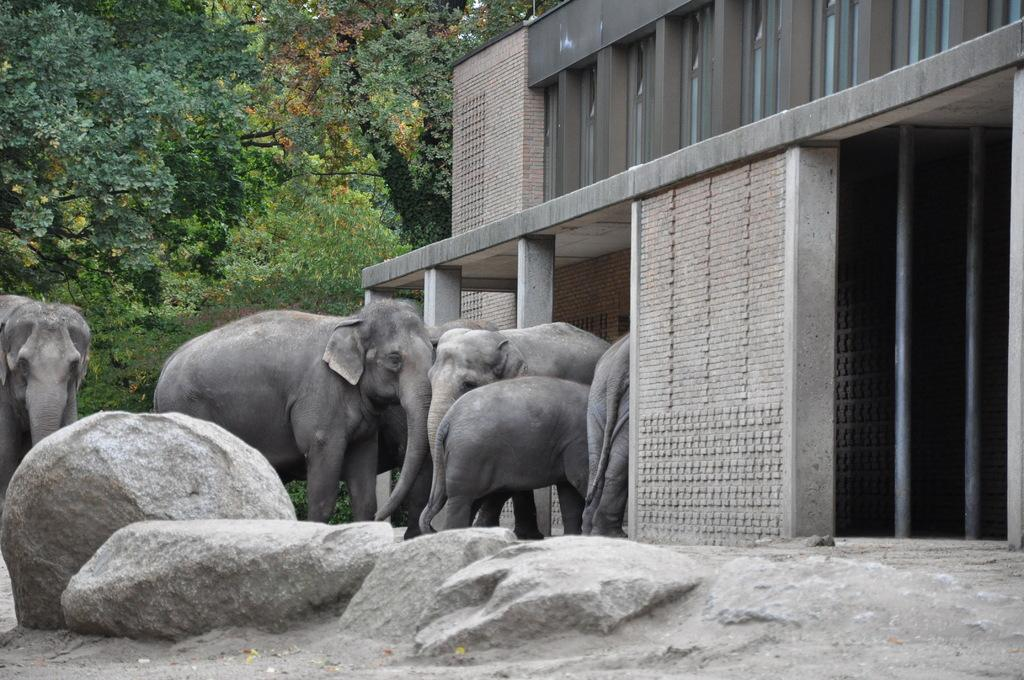What animals are present in the image? There are many elephants in the image. What structure can be seen on the right side of the image? There is a building on the right side of the image. What type of terrain is depicted in the image? There are stones on the ground in the image. What can be seen in the distance in the image? There are trees visible in the background of the image. How many oranges are being harvested by the elephants in the image? There are no oranges present in the image, and the elephants are not depicted as harvesting anything. 